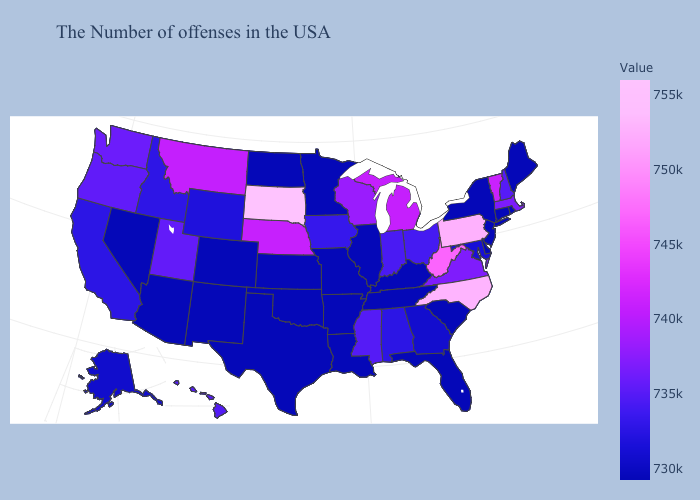Does Missouri have the highest value in the USA?
Answer briefly. No. Does Connecticut have the highest value in the USA?
Be succinct. No. Does North Carolina have a lower value than South Dakota?
Short answer required. Yes. Does New York have the highest value in the USA?
Keep it brief. No. 